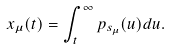Convert formula to latex. <formula><loc_0><loc_0><loc_500><loc_500>x _ { \mu } ( t ) = \int _ { t } ^ { \infty } p _ { s _ { \mu } } ( u ) d u .</formula> 